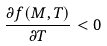Convert formula to latex. <formula><loc_0><loc_0><loc_500><loc_500>\frac { \partial f ( M , T ) } { \partial T } < 0</formula> 